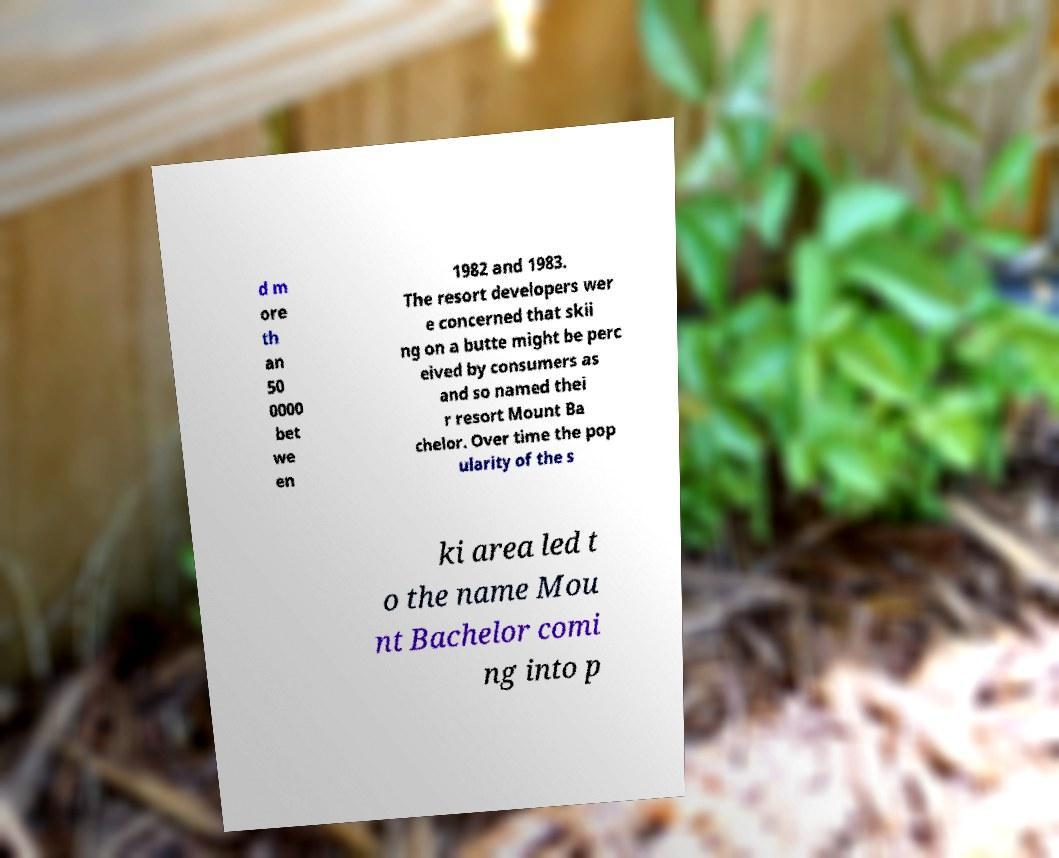Could you assist in decoding the text presented in this image and type it out clearly? d m ore th an 50 0000 bet we en 1982 and 1983. The resort developers wer e concerned that skii ng on a butte might be perc eived by consumers as and so named thei r resort Mount Ba chelor. Over time the pop ularity of the s ki area led t o the name Mou nt Bachelor comi ng into p 